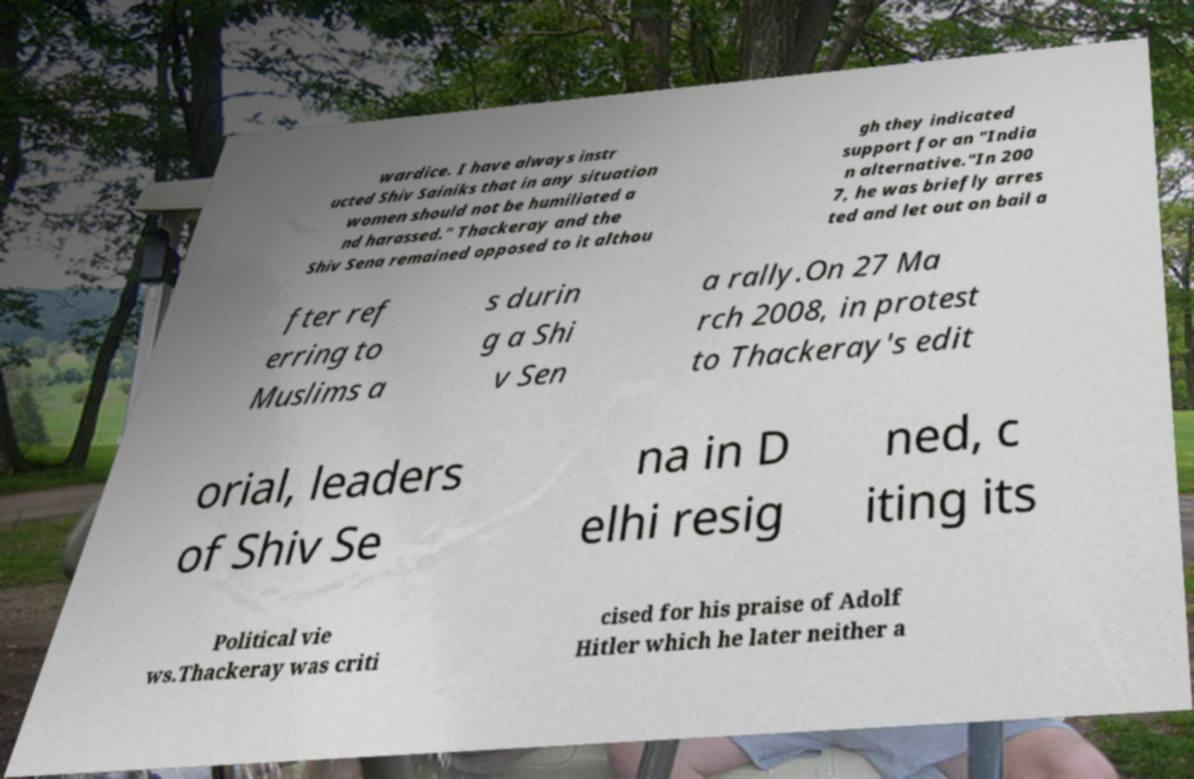Please read and relay the text visible in this image. What does it say? wardice. I have always instr ucted Shiv Sainiks that in any situation women should not be humiliated a nd harassed." Thackeray and the Shiv Sena remained opposed to it althou gh they indicated support for an "India n alternative."In 200 7, he was briefly arres ted and let out on bail a fter ref erring to Muslims a s durin g a Shi v Sen a rally.On 27 Ma rch 2008, in protest to Thackeray's edit orial, leaders of Shiv Se na in D elhi resig ned, c iting its Political vie ws.Thackeray was criti cised for his praise of Adolf Hitler which he later neither a 